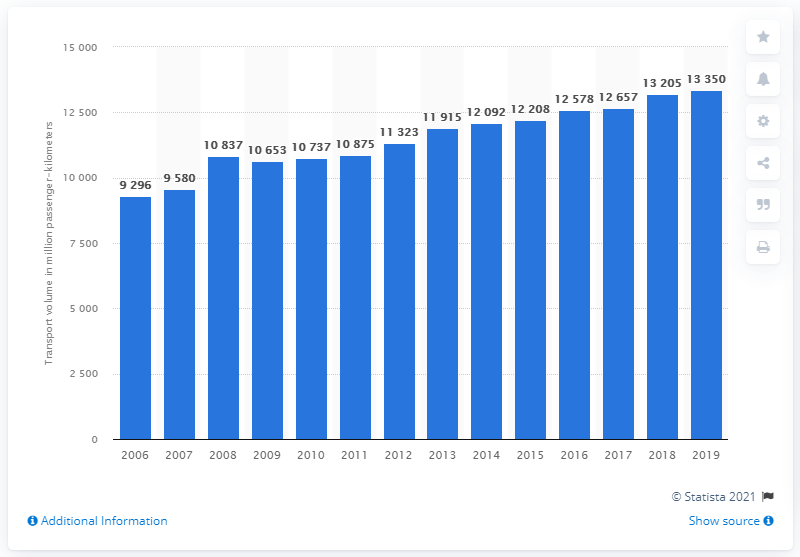Mention a couple of crucial points in this snapshot. In 2019, Austria's passenger rail transport volume was 13,350. 